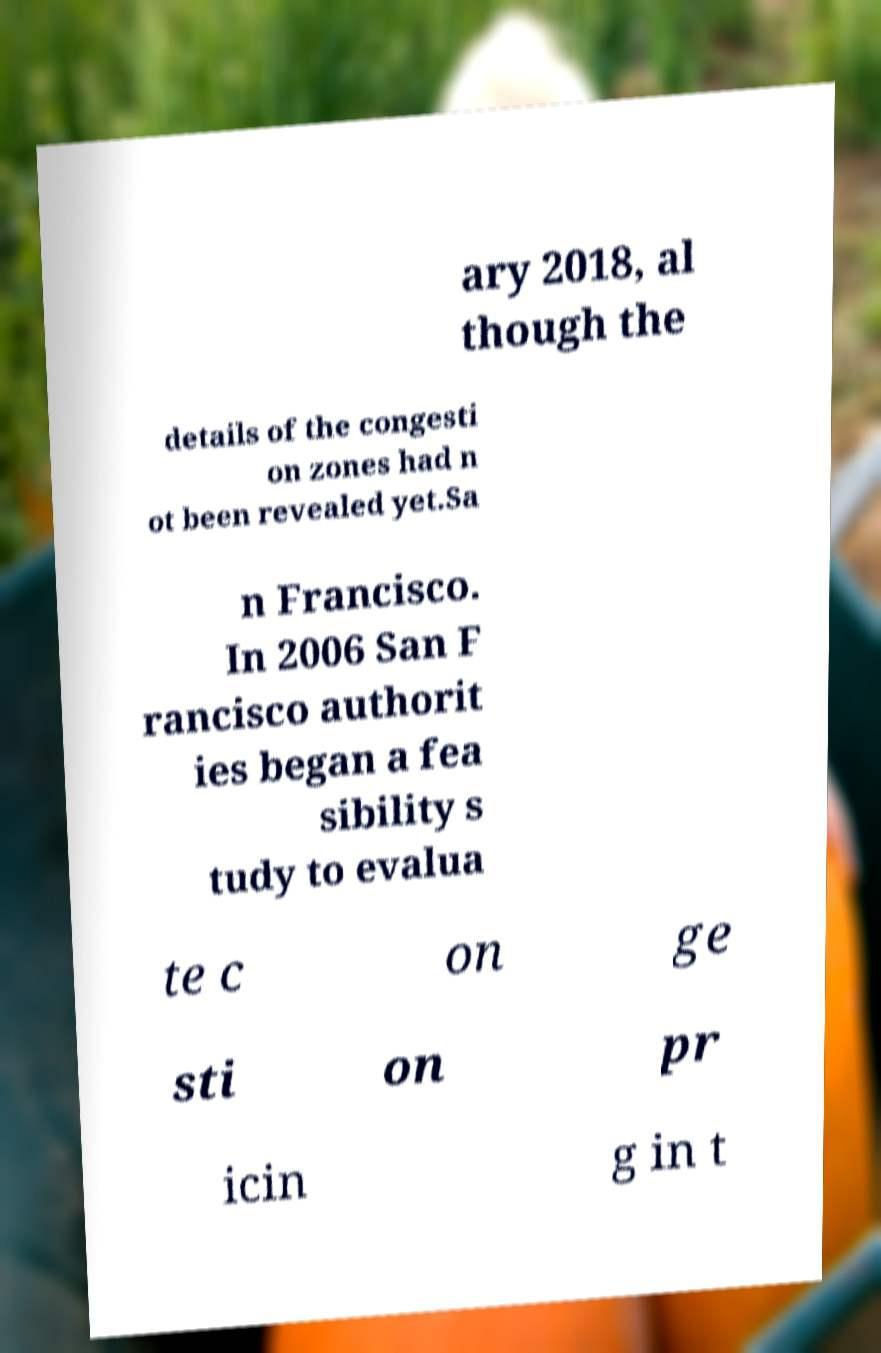I need the written content from this picture converted into text. Can you do that? ary 2018, al though the details of the congesti on zones had n ot been revealed yet.Sa n Francisco. In 2006 San F rancisco authorit ies began a fea sibility s tudy to evalua te c on ge sti on pr icin g in t 